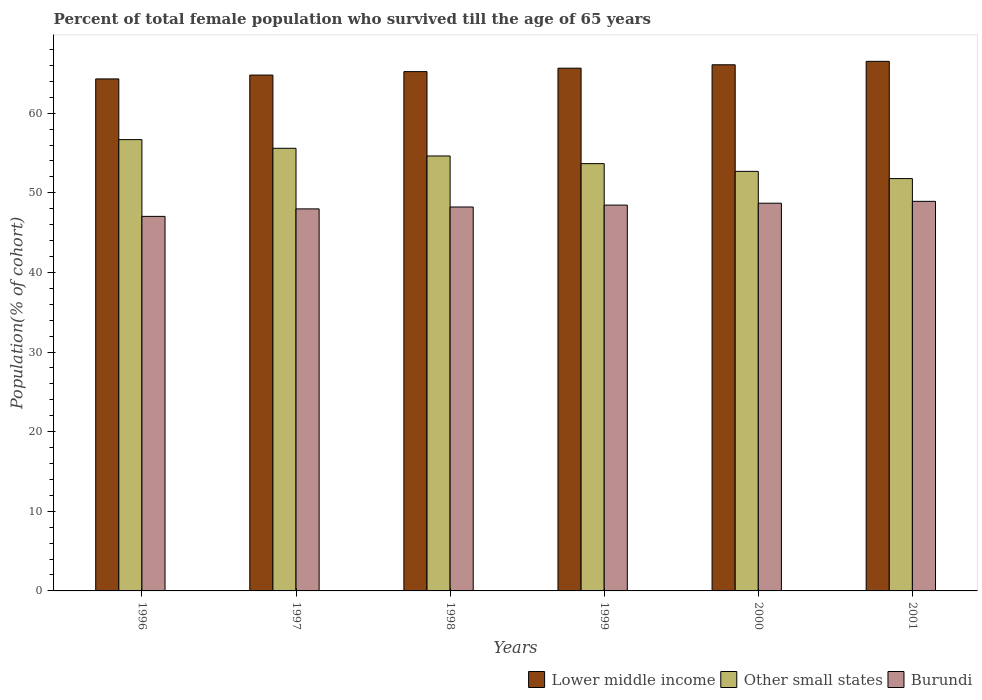How many bars are there on the 1st tick from the left?
Offer a terse response. 3. How many bars are there on the 4th tick from the right?
Give a very brief answer. 3. What is the percentage of total female population who survived till the age of 65 years in Burundi in 1997?
Ensure brevity in your answer.  47.98. Across all years, what is the maximum percentage of total female population who survived till the age of 65 years in Burundi?
Keep it short and to the point. 48.93. Across all years, what is the minimum percentage of total female population who survived till the age of 65 years in Other small states?
Give a very brief answer. 51.78. In which year was the percentage of total female population who survived till the age of 65 years in Burundi maximum?
Ensure brevity in your answer.  2001. In which year was the percentage of total female population who survived till the age of 65 years in Burundi minimum?
Ensure brevity in your answer.  1996. What is the total percentage of total female population who survived till the age of 65 years in Burundi in the graph?
Provide a succinct answer. 289.3. What is the difference between the percentage of total female population who survived till the age of 65 years in Other small states in 1996 and that in 1997?
Your response must be concise. 1.09. What is the difference between the percentage of total female population who survived till the age of 65 years in Burundi in 1997 and the percentage of total female population who survived till the age of 65 years in Lower middle income in 2001?
Ensure brevity in your answer.  -18.53. What is the average percentage of total female population who survived till the age of 65 years in Other small states per year?
Offer a terse response. 54.17. In the year 1996, what is the difference between the percentage of total female population who survived till the age of 65 years in Lower middle income and percentage of total female population who survived till the age of 65 years in Burundi?
Your response must be concise. 17.27. What is the ratio of the percentage of total female population who survived till the age of 65 years in Lower middle income in 1996 to that in 2001?
Provide a succinct answer. 0.97. What is the difference between the highest and the second highest percentage of total female population who survived till the age of 65 years in Other small states?
Keep it short and to the point. 1.09. What is the difference between the highest and the lowest percentage of total female population who survived till the age of 65 years in Burundi?
Offer a terse response. 1.89. In how many years, is the percentage of total female population who survived till the age of 65 years in Lower middle income greater than the average percentage of total female population who survived till the age of 65 years in Lower middle income taken over all years?
Provide a short and direct response. 3. Is the sum of the percentage of total female population who survived till the age of 65 years in Other small states in 1997 and 2001 greater than the maximum percentage of total female population who survived till the age of 65 years in Burundi across all years?
Keep it short and to the point. Yes. What does the 1st bar from the left in 1996 represents?
Give a very brief answer. Lower middle income. What does the 3rd bar from the right in 2001 represents?
Your answer should be compact. Lower middle income. Is it the case that in every year, the sum of the percentage of total female population who survived till the age of 65 years in Lower middle income and percentage of total female population who survived till the age of 65 years in Other small states is greater than the percentage of total female population who survived till the age of 65 years in Burundi?
Your answer should be very brief. Yes. Are all the bars in the graph horizontal?
Your answer should be very brief. No. What is the difference between two consecutive major ticks on the Y-axis?
Provide a short and direct response. 10. Does the graph contain any zero values?
Provide a succinct answer. No. How are the legend labels stacked?
Give a very brief answer. Horizontal. What is the title of the graph?
Your response must be concise. Percent of total female population who survived till the age of 65 years. What is the label or title of the Y-axis?
Provide a succinct answer. Population(% of cohort). What is the Population(% of cohort) of Lower middle income in 1996?
Offer a very short reply. 64.3. What is the Population(% of cohort) in Other small states in 1996?
Your answer should be very brief. 56.68. What is the Population(% of cohort) of Burundi in 1996?
Provide a short and direct response. 47.04. What is the Population(% of cohort) of Lower middle income in 1997?
Offer a very short reply. 64.79. What is the Population(% of cohort) in Other small states in 1997?
Make the answer very short. 55.59. What is the Population(% of cohort) of Burundi in 1997?
Provide a succinct answer. 47.98. What is the Population(% of cohort) in Lower middle income in 1998?
Keep it short and to the point. 65.22. What is the Population(% of cohort) in Other small states in 1998?
Offer a terse response. 54.62. What is the Population(% of cohort) of Burundi in 1998?
Provide a succinct answer. 48.22. What is the Population(% of cohort) in Lower middle income in 1999?
Offer a terse response. 65.65. What is the Population(% of cohort) of Other small states in 1999?
Provide a short and direct response. 53.66. What is the Population(% of cohort) in Burundi in 1999?
Keep it short and to the point. 48.45. What is the Population(% of cohort) of Lower middle income in 2000?
Give a very brief answer. 66.08. What is the Population(% of cohort) of Other small states in 2000?
Ensure brevity in your answer.  52.69. What is the Population(% of cohort) of Burundi in 2000?
Offer a very short reply. 48.69. What is the Population(% of cohort) in Lower middle income in 2001?
Ensure brevity in your answer.  66.51. What is the Population(% of cohort) of Other small states in 2001?
Provide a succinct answer. 51.78. What is the Population(% of cohort) in Burundi in 2001?
Ensure brevity in your answer.  48.93. Across all years, what is the maximum Population(% of cohort) of Lower middle income?
Keep it short and to the point. 66.51. Across all years, what is the maximum Population(% of cohort) in Other small states?
Your response must be concise. 56.68. Across all years, what is the maximum Population(% of cohort) in Burundi?
Ensure brevity in your answer.  48.93. Across all years, what is the minimum Population(% of cohort) in Lower middle income?
Provide a succinct answer. 64.3. Across all years, what is the minimum Population(% of cohort) in Other small states?
Offer a very short reply. 51.78. Across all years, what is the minimum Population(% of cohort) of Burundi?
Provide a succinct answer. 47.04. What is the total Population(% of cohort) of Lower middle income in the graph?
Ensure brevity in your answer.  392.54. What is the total Population(% of cohort) in Other small states in the graph?
Your answer should be compact. 325.03. What is the total Population(% of cohort) in Burundi in the graph?
Your answer should be very brief. 289.3. What is the difference between the Population(% of cohort) in Lower middle income in 1996 and that in 1997?
Your answer should be very brief. -0.48. What is the difference between the Population(% of cohort) of Other small states in 1996 and that in 1997?
Ensure brevity in your answer.  1.09. What is the difference between the Population(% of cohort) of Burundi in 1996 and that in 1997?
Provide a succinct answer. -0.94. What is the difference between the Population(% of cohort) in Lower middle income in 1996 and that in 1998?
Keep it short and to the point. -0.92. What is the difference between the Population(% of cohort) in Other small states in 1996 and that in 1998?
Make the answer very short. 2.05. What is the difference between the Population(% of cohort) of Burundi in 1996 and that in 1998?
Offer a very short reply. -1.18. What is the difference between the Population(% of cohort) of Lower middle income in 1996 and that in 1999?
Keep it short and to the point. -1.35. What is the difference between the Population(% of cohort) in Other small states in 1996 and that in 1999?
Your answer should be compact. 3.02. What is the difference between the Population(% of cohort) of Burundi in 1996 and that in 1999?
Ensure brevity in your answer.  -1.42. What is the difference between the Population(% of cohort) in Lower middle income in 1996 and that in 2000?
Keep it short and to the point. -1.77. What is the difference between the Population(% of cohort) in Other small states in 1996 and that in 2000?
Your response must be concise. 3.99. What is the difference between the Population(% of cohort) of Burundi in 1996 and that in 2000?
Offer a very short reply. -1.65. What is the difference between the Population(% of cohort) in Lower middle income in 1996 and that in 2001?
Keep it short and to the point. -2.2. What is the difference between the Population(% of cohort) in Other small states in 1996 and that in 2001?
Your answer should be compact. 4.89. What is the difference between the Population(% of cohort) of Burundi in 1996 and that in 2001?
Your response must be concise. -1.89. What is the difference between the Population(% of cohort) of Lower middle income in 1997 and that in 1998?
Provide a succinct answer. -0.43. What is the difference between the Population(% of cohort) of Other small states in 1997 and that in 1998?
Ensure brevity in your answer.  0.97. What is the difference between the Population(% of cohort) of Burundi in 1997 and that in 1998?
Give a very brief answer. -0.24. What is the difference between the Population(% of cohort) of Lower middle income in 1997 and that in 1999?
Keep it short and to the point. -0.86. What is the difference between the Population(% of cohort) in Other small states in 1997 and that in 1999?
Offer a very short reply. 1.93. What is the difference between the Population(% of cohort) of Burundi in 1997 and that in 1999?
Your answer should be compact. -0.47. What is the difference between the Population(% of cohort) of Lower middle income in 1997 and that in 2000?
Keep it short and to the point. -1.29. What is the difference between the Population(% of cohort) of Other small states in 1997 and that in 2000?
Provide a succinct answer. 2.9. What is the difference between the Population(% of cohort) in Burundi in 1997 and that in 2000?
Your answer should be compact. -0.71. What is the difference between the Population(% of cohort) of Lower middle income in 1997 and that in 2001?
Ensure brevity in your answer.  -1.72. What is the difference between the Population(% of cohort) in Other small states in 1997 and that in 2001?
Provide a short and direct response. 3.81. What is the difference between the Population(% of cohort) in Burundi in 1997 and that in 2001?
Give a very brief answer. -0.95. What is the difference between the Population(% of cohort) in Lower middle income in 1998 and that in 1999?
Ensure brevity in your answer.  -0.43. What is the difference between the Population(% of cohort) in Other small states in 1998 and that in 1999?
Your response must be concise. 0.96. What is the difference between the Population(% of cohort) of Burundi in 1998 and that in 1999?
Provide a short and direct response. -0.24. What is the difference between the Population(% of cohort) in Lower middle income in 1998 and that in 2000?
Offer a terse response. -0.86. What is the difference between the Population(% of cohort) of Other small states in 1998 and that in 2000?
Offer a very short reply. 1.93. What is the difference between the Population(% of cohort) in Burundi in 1998 and that in 2000?
Ensure brevity in your answer.  -0.47. What is the difference between the Population(% of cohort) of Lower middle income in 1998 and that in 2001?
Ensure brevity in your answer.  -1.29. What is the difference between the Population(% of cohort) of Other small states in 1998 and that in 2001?
Offer a terse response. 2.84. What is the difference between the Population(% of cohort) in Burundi in 1998 and that in 2001?
Your answer should be very brief. -0.71. What is the difference between the Population(% of cohort) in Lower middle income in 1999 and that in 2000?
Your answer should be compact. -0.43. What is the difference between the Population(% of cohort) in Other small states in 1999 and that in 2000?
Provide a short and direct response. 0.97. What is the difference between the Population(% of cohort) of Burundi in 1999 and that in 2000?
Your response must be concise. -0.24. What is the difference between the Population(% of cohort) in Lower middle income in 1999 and that in 2001?
Ensure brevity in your answer.  -0.86. What is the difference between the Population(% of cohort) of Other small states in 1999 and that in 2001?
Your answer should be very brief. 1.88. What is the difference between the Population(% of cohort) of Burundi in 1999 and that in 2001?
Your response must be concise. -0.47. What is the difference between the Population(% of cohort) in Lower middle income in 2000 and that in 2001?
Your answer should be compact. -0.43. What is the difference between the Population(% of cohort) of Other small states in 2000 and that in 2001?
Offer a very short reply. 0.91. What is the difference between the Population(% of cohort) of Burundi in 2000 and that in 2001?
Keep it short and to the point. -0.24. What is the difference between the Population(% of cohort) in Lower middle income in 1996 and the Population(% of cohort) in Other small states in 1997?
Your answer should be very brief. 8.71. What is the difference between the Population(% of cohort) in Lower middle income in 1996 and the Population(% of cohort) in Burundi in 1997?
Offer a terse response. 16.32. What is the difference between the Population(% of cohort) of Other small states in 1996 and the Population(% of cohort) of Burundi in 1997?
Provide a succinct answer. 8.7. What is the difference between the Population(% of cohort) in Lower middle income in 1996 and the Population(% of cohort) in Other small states in 1998?
Ensure brevity in your answer.  9.68. What is the difference between the Population(% of cohort) in Lower middle income in 1996 and the Population(% of cohort) in Burundi in 1998?
Offer a terse response. 16.09. What is the difference between the Population(% of cohort) in Other small states in 1996 and the Population(% of cohort) in Burundi in 1998?
Offer a terse response. 8.46. What is the difference between the Population(% of cohort) of Lower middle income in 1996 and the Population(% of cohort) of Other small states in 1999?
Provide a short and direct response. 10.64. What is the difference between the Population(% of cohort) of Lower middle income in 1996 and the Population(% of cohort) of Burundi in 1999?
Provide a short and direct response. 15.85. What is the difference between the Population(% of cohort) in Other small states in 1996 and the Population(% of cohort) in Burundi in 1999?
Offer a very short reply. 8.22. What is the difference between the Population(% of cohort) in Lower middle income in 1996 and the Population(% of cohort) in Other small states in 2000?
Keep it short and to the point. 11.61. What is the difference between the Population(% of cohort) in Lower middle income in 1996 and the Population(% of cohort) in Burundi in 2000?
Keep it short and to the point. 15.61. What is the difference between the Population(% of cohort) in Other small states in 1996 and the Population(% of cohort) in Burundi in 2000?
Give a very brief answer. 7.99. What is the difference between the Population(% of cohort) in Lower middle income in 1996 and the Population(% of cohort) in Other small states in 2001?
Ensure brevity in your answer.  12.52. What is the difference between the Population(% of cohort) of Lower middle income in 1996 and the Population(% of cohort) of Burundi in 2001?
Your answer should be compact. 15.37. What is the difference between the Population(% of cohort) of Other small states in 1996 and the Population(% of cohort) of Burundi in 2001?
Make the answer very short. 7.75. What is the difference between the Population(% of cohort) of Lower middle income in 1997 and the Population(% of cohort) of Other small states in 1998?
Your answer should be compact. 10.16. What is the difference between the Population(% of cohort) in Lower middle income in 1997 and the Population(% of cohort) in Burundi in 1998?
Your response must be concise. 16.57. What is the difference between the Population(% of cohort) in Other small states in 1997 and the Population(% of cohort) in Burundi in 1998?
Give a very brief answer. 7.37. What is the difference between the Population(% of cohort) in Lower middle income in 1997 and the Population(% of cohort) in Other small states in 1999?
Provide a succinct answer. 11.12. What is the difference between the Population(% of cohort) in Lower middle income in 1997 and the Population(% of cohort) in Burundi in 1999?
Make the answer very short. 16.33. What is the difference between the Population(% of cohort) in Other small states in 1997 and the Population(% of cohort) in Burundi in 1999?
Your answer should be very brief. 7.14. What is the difference between the Population(% of cohort) in Lower middle income in 1997 and the Population(% of cohort) in Other small states in 2000?
Make the answer very short. 12.09. What is the difference between the Population(% of cohort) of Lower middle income in 1997 and the Population(% of cohort) of Burundi in 2000?
Your answer should be compact. 16.09. What is the difference between the Population(% of cohort) of Other small states in 1997 and the Population(% of cohort) of Burundi in 2000?
Offer a terse response. 6.9. What is the difference between the Population(% of cohort) in Lower middle income in 1997 and the Population(% of cohort) in Other small states in 2001?
Give a very brief answer. 13. What is the difference between the Population(% of cohort) of Lower middle income in 1997 and the Population(% of cohort) of Burundi in 2001?
Your answer should be very brief. 15.86. What is the difference between the Population(% of cohort) of Other small states in 1997 and the Population(% of cohort) of Burundi in 2001?
Offer a very short reply. 6.66. What is the difference between the Population(% of cohort) in Lower middle income in 1998 and the Population(% of cohort) in Other small states in 1999?
Offer a terse response. 11.56. What is the difference between the Population(% of cohort) in Lower middle income in 1998 and the Population(% of cohort) in Burundi in 1999?
Offer a terse response. 16.76. What is the difference between the Population(% of cohort) of Other small states in 1998 and the Population(% of cohort) of Burundi in 1999?
Provide a short and direct response. 6.17. What is the difference between the Population(% of cohort) of Lower middle income in 1998 and the Population(% of cohort) of Other small states in 2000?
Your response must be concise. 12.53. What is the difference between the Population(% of cohort) in Lower middle income in 1998 and the Population(% of cohort) in Burundi in 2000?
Ensure brevity in your answer.  16.53. What is the difference between the Population(% of cohort) of Other small states in 1998 and the Population(% of cohort) of Burundi in 2000?
Offer a terse response. 5.93. What is the difference between the Population(% of cohort) of Lower middle income in 1998 and the Population(% of cohort) of Other small states in 2001?
Your response must be concise. 13.43. What is the difference between the Population(% of cohort) of Lower middle income in 1998 and the Population(% of cohort) of Burundi in 2001?
Offer a very short reply. 16.29. What is the difference between the Population(% of cohort) in Other small states in 1998 and the Population(% of cohort) in Burundi in 2001?
Keep it short and to the point. 5.7. What is the difference between the Population(% of cohort) in Lower middle income in 1999 and the Population(% of cohort) in Other small states in 2000?
Your answer should be compact. 12.96. What is the difference between the Population(% of cohort) of Lower middle income in 1999 and the Population(% of cohort) of Burundi in 2000?
Your response must be concise. 16.96. What is the difference between the Population(% of cohort) in Other small states in 1999 and the Population(% of cohort) in Burundi in 2000?
Ensure brevity in your answer.  4.97. What is the difference between the Population(% of cohort) in Lower middle income in 1999 and the Population(% of cohort) in Other small states in 2001?
Ensure brevity in your answer.  13.87. What is the difference between the Population(% of cohort) in Lower middle income in 1999 and the Population(% of cohort) in Burundi in 2001?
Offer a very short reply. 16.72. What is the difference between the Population(% of cohort) in Other small states in 1999 and the Population(% of cohort) in Burundi in 2001?
Provide a succinct answer. 4.73. What is the difference between the Population(% of cohort) of Lower middle income in 2000 and the Population(% of cohort) of Other small states in 2001?
Your answer should be compact. 14.29. What is the difference between the Population(% of cohort) of Lower middle income in 2000 and the Population(% of cohort) of Burundi in 2001?
Keep it short and to the point. 17.15. What is the difference between the Population(% of cohort) of Other small states in 2000 and the Population(% of cohort) of Burundi in 2001?
Keep it short and to the point. 3.76. What is the average Population(% of cohort) in Lower middle income per year?
Ensure brevity in your answer.  65.42. What is the average Population(% of cohort) of Other small states per year?
Give a very brief answer. 54.17. What is the average Population(% of cohort) of Burundi per year?
Provide a short and direct response. 48.22. In the year 1996, what is the difference between the Population(% of cohort) in Lower middle income and Population(% of cohort) in Other small states?
Your answer should be very brief. 7.62. In the year 1996, what is the difference between the Population(% of cohort) in Lower middle income and Population(% of cohort) in Burundi?
Offer a very short reply. 17.27. In the year 1996, what is the difference between the Population(% of cohort) in Other small states and Population(% of cohort) in Burundi?
Provide a short and direct response. 9.64. In the year 1997, what is the difference between the Population(% of cohort) of Lower middle income and Population(% of cohort) of Other small states?
Provide a short and direct response. 9.2. In the year 1997, what is the difference between the Population(% of cohort) of Lower middle income and Population(% of cohort) of Burundi?
Keep it short and to the point. 16.81. In the year 1997, what is the difference between the Population(% of cohort) in Other small states and Population(% of cohort) in Burundi?
Your answer should be compact. 7.61. In the year 1998, what is the difference between the Population(% of cohort) in Lower middle income and Population(% of cohort) in Other small states?
Your answer should be compact. 10.59. In the year 1998, what is the difference between the Population(% of cohort) in Lower middle income and Population(% of cohort) in Burundi?
Your answer should be compact. 17. In the year 1998, what is the difference between the Population(% of cohort) of Other small states and Population(% of cohort) of Burundi?
Your answer should be compact. 6.41. In the year 1999, what is the difference between the Population(% of cohort) of Lower middle income and Population(% of cohort) of Other small states?
Ensure brevity in your answer.  11.99. In the year 1999, what is the difference between the Population(% of cohort) in Lower middle income and Population(% of cohort) in Burundi?
Your response must be concise. 17.2. In the year 1999, what is the difference between the Population(% of cohort) of Other small states and Population(% of cohort) of Burundi?
Keep it short and to the point. 5.21. In the year 2000, what is the difference between the Population(% of cohort) in Lower middle income and Population(% of cohort) in Other small states?
Provide a short and direct response. 13.38. In the year 2000, what is the difference between the Population(% of cohort) of Lower middle income and Population(% of cohort) of Burundi?
Provide a short and direct response. 17.39. In the year 2000, what is the difference between the Population(% of cohort) in Other small states and Population(% of cohort) in Burundi?
Give a very brief answer. 4. In the year 2001, what is the difference between the Population(% of cohort) of Lower middle income and Population(% of cohort) of Other small states?
Your response must be concise. 14.72. In the year 2001, what is the difference between the Population(% of cohort) in Lower middle income and Population(% of cohort) in Burundi?
Keep it short and to the point. 17.58. In the year 2001, what is the difference between the Population(% of cohort) of Other small states and Population(% of cohort) of Burundi?
Provide a short and direct response. 2.86. What is the ratio of the Population(% of cohort) in Other small states in 1996 to that in 1997?
Your response must be concise. 1.02. What is the ratio of the Population(% of cohort) of Burundi in 1996 to that in 1997?
Make the answer very short. 0.98. What is the ratio of the Population(% of cohort) of Lower middle income in 1996 to that in 1998?
Your answer should be compact. 0.99. What is the ratio of the Population(% of cohort) of Other small states in 1996 to that in 1998?
Offer a very short reply. 1.04. What is the ratio of the Population(% of cohort) of Burundi in 1996 to that in 1998?
Offer a terse response. 0.98. What is the ratio of the Population(% of cohort) of Lower middle income in 1996 to that in 1999?
Provide a succinct answer. 0.98. What is the ratio of the Population(% of cohort) of Other small states in 1996 to that in 1999?
Make the answer very short. 1.06. What is the ratio of the Population(% of cohort) of Burundi in 1996 to that in 1999?
Make the answer very short. 0.97. What is the ratio of the Population(% of cohort) in Lower middle income in 1996 to that in 2000?
Provide a succinct answer. 0.97. What is the ratio of the Population(% of cohort) of Other small states in 1996 to that in 2000?
Offer a terse response. 1.08. What is the ratio of the Population(% of cohort) in Lower middle income in 1996 to that in 2001?
Keep it short and to the point. 0.97. What is the ratio of the Population(% of cohort) in Other small states in 1996 to that in 2001?
Your answer should be compact. 1.09. What is the ratio of the Population(% of cohort) of Burundi in 1996 to that in 2001?
Your answer should be compact. 0.96. What is the ratio of the Population(% of cohort) of Lower middle income in 1997 to that in 1998?
Give a very brief answer. 0.99. What is the ratio of the Population(% of cohort) in Other small states in 1997 to that in 1998?
Keep it short and to the point. 1.02. What is the ratio of the Population(% of cohort) in Other small states in 1997 to that in 1999?
Ensure brevity in your answer.  1.04. What is the ratio of the Population(% of cohort) of Burundi in 1997 to that in 1999?
Your answer should be compact. 0.99. What is the ratio of the Population(% of cohort) in Lower middle income in 1997 to that in 2000?
Provide a succinct answer. 0.98. What is the ratio of the Population(% of cohort) of Other small states in 1997 to that in 2000?
Give a very brief answer. 1.05. What is the ratio of the Population(% of cohort) in Burundi in 1997 to that in 2000?
Offer a very short reply. 0.99. What is the ratio of the Population(% of cohort) of Lower middle income in 1997 to that in 2001?
Ensure brevity in your answer.  0.97. What is the ratio of the Population(% of cohort) in Other small states in 1997 to that in 2001?
Your response must be concise. 1.07. What is the ratio of the Population(% of cohort) in Burundi in 1997 to that in 2001?
Your answer should be very brief. 0.98. What is the ratio of the Population(% of cohort) of Lower middle income in 1998 to that in 1999?
Offer a very short reply. 0.99. What is the ratio of the Population(% of cohort) in Other small states in 1998 to that in 1999?
Offer a terse response. 1.02. What is the ratio of the Population(% of cohort) of Burundi in 1998 to that in 1999?
Offer a terse response. 1. What is the ratio of the Population(% of cohort) in Lower middle income in 1998 to that in 2000?
Your response must be concise. 0.99. What is the ratio of the Population(% of cohort) of Other small states in 1998 to that in 2000?
Offer a terse response. 1.04. What is the ratio of the Population(% of cohort) of Burundi in 1998 to that in 2000?
Your answer should be very brief. 0.99. What is the ratio of the Population(% of cohort) of Lower middle income in 1998 to that in 2001?
Offer a terse response. 0.98. What is the ratio of the Population(% of cohort) in Other small states in 1998 to that in 2001?
Your answer should be very brief. 1.05. What is the ratio of the Population(% of cohort) in Burundi in 1998 to that in 2001?
Your answer should be very brief. 0.99. What is the ratio of the Population(% of cohort) of Other small states in 1999 to that in 2000?
Provide a succinct answer. 1.02. What is the ratio of the Population(% of cohort) of Burundi in 1999 to that in 2000?
Give a very brief answer. 1. What is the ratio of the Population(% of cohort) of Lower middle income in 1999 to that in 2001?
Your answer should be very brief. 0.99. What is the ratio of the Population(% of cohort) in Other small states in 1999 to that in 2001?
Your answer should be very brief. 1.04. What is the ratio of the Population(% of cohort) of Burundi in 1999 to that in 2001?
Your answer should be very brief. 0.99. What is the ratio of the Population(% of cohort) of Other small states in 2000 to that in 2001?
Your answer should be very brief. 1.02. What is the difference between the highest and the second highest Population(% of cohort) in Lower middle income?
Provide a short and direct response. 0.43. What is the difference between the highest and the second highest Population(% of cohort) in Other small states?
Provide a short and direct response. 1.09. What is the difference between the highest and the second highest Population(% of cohort) of Burundi?
Provide a short and direct response. 0.24. What is the difference between the highest and the lowest Population(% of cohort) in Lower middle income?
Make the answer very short. 2.2. What is the difference between the highest and the lowest Population(% of cohort) in Other small states?
Offer a terse response. 4.89. What is the difference between the highest and the lowest Population(% of cohort) of Burundi?
Your answer should be very brief. 1.89. 